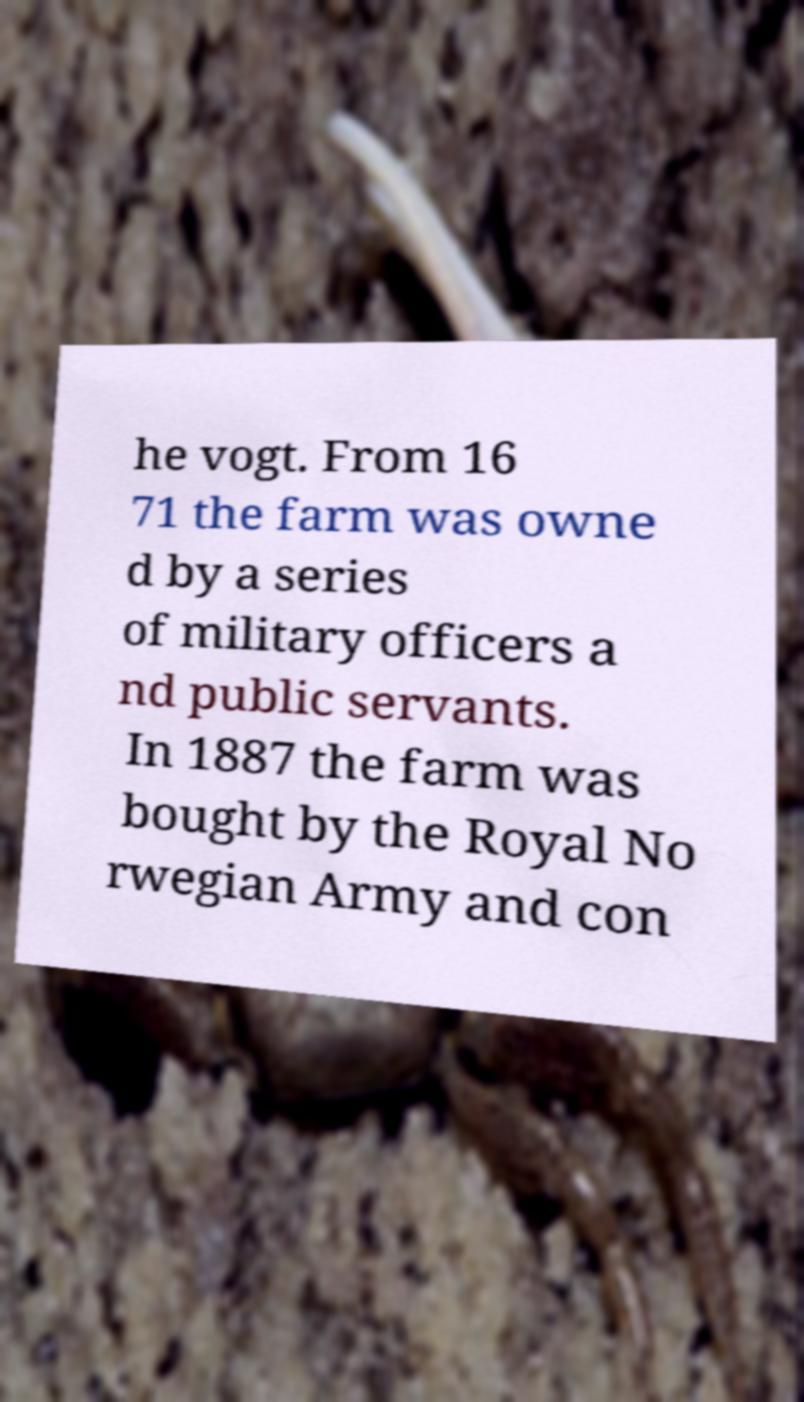Can you read and provide the text displayed in the image?This photo seems to have some interesting text. Can you extract and type it out for me? he vogt. From 16 71 the farm was owne d by a series of military officers a nd public servants. In 1887 the farm was bought by the Royal No rwegian Army and con 